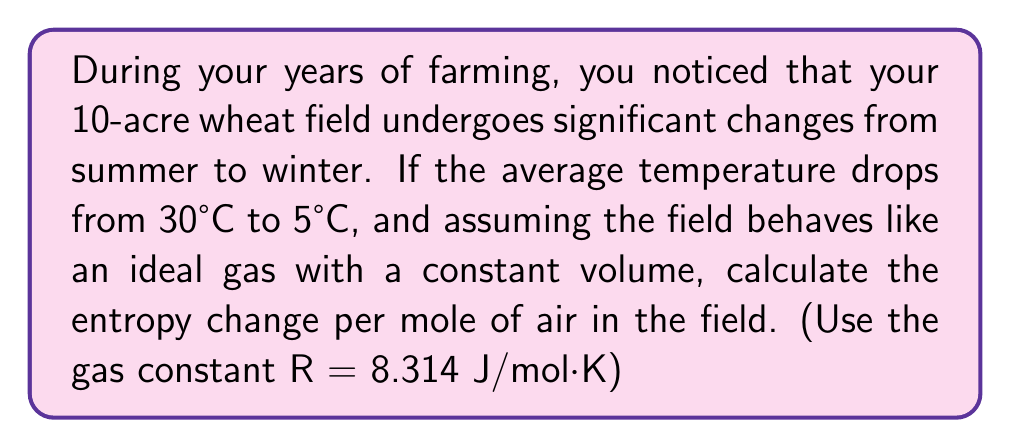Show me your answer to this math problem. Let's approach this step-by-step:

1) For an ideal gas at constant volume, the entropy change is given by:

   $$\Delta S = nC_v \ln\left(\frac{T_2}{T_1}\right)$$

   where $n$ is the number of moles, $C_v$ is the specific heat capacity at constant volume, $T_1$ is the initial temperature, and $T_2$ is the final temperature.

2) For an ideal monatomic gas, $C_v = \frac{3}{2}R$. We'll use this approximation for air.

3) We need to convert the temperatures to Kelvin:
   $T_1 = 30°C + 273.15 = 303.15$ K
   $T_2 = 5°C + 273.15 = 278.15$ K

4) Substituting into our equation:

   $$\Delta S = \frac{3}{2}R \ln\left(\frac{278.15}{303.15}\right)$$

5) Simplify:

   $$\Delta S = \frac{3}{2} \cdot 8.314 \cdot \ln\left(\frac{278.15}{303.15}\right)$$
   $$\Delta S = 12.471 \cdot (-0.0857)$$
   $$\Delta S = -1.069 \text{ J/mol·K}$$

The negative value indicates a decrease in entropy as the temperature drops.
Answer: $-1.069$ J/mol·K 